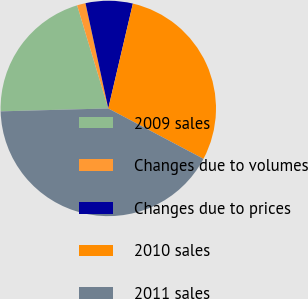<chart> <loc_0><loc_0><loc_500><loc_500><pie_chart><fcel>2009 sales<fcel>Changes due to volumes<fcel>Changes due to prices<fcel>2010 sales<fcel>2011 sales<nl><fcel>20.76%<fcel>1.28%<fcel>7.06%<fcel>29.09%<fcel>41.82%<nl></chart> 